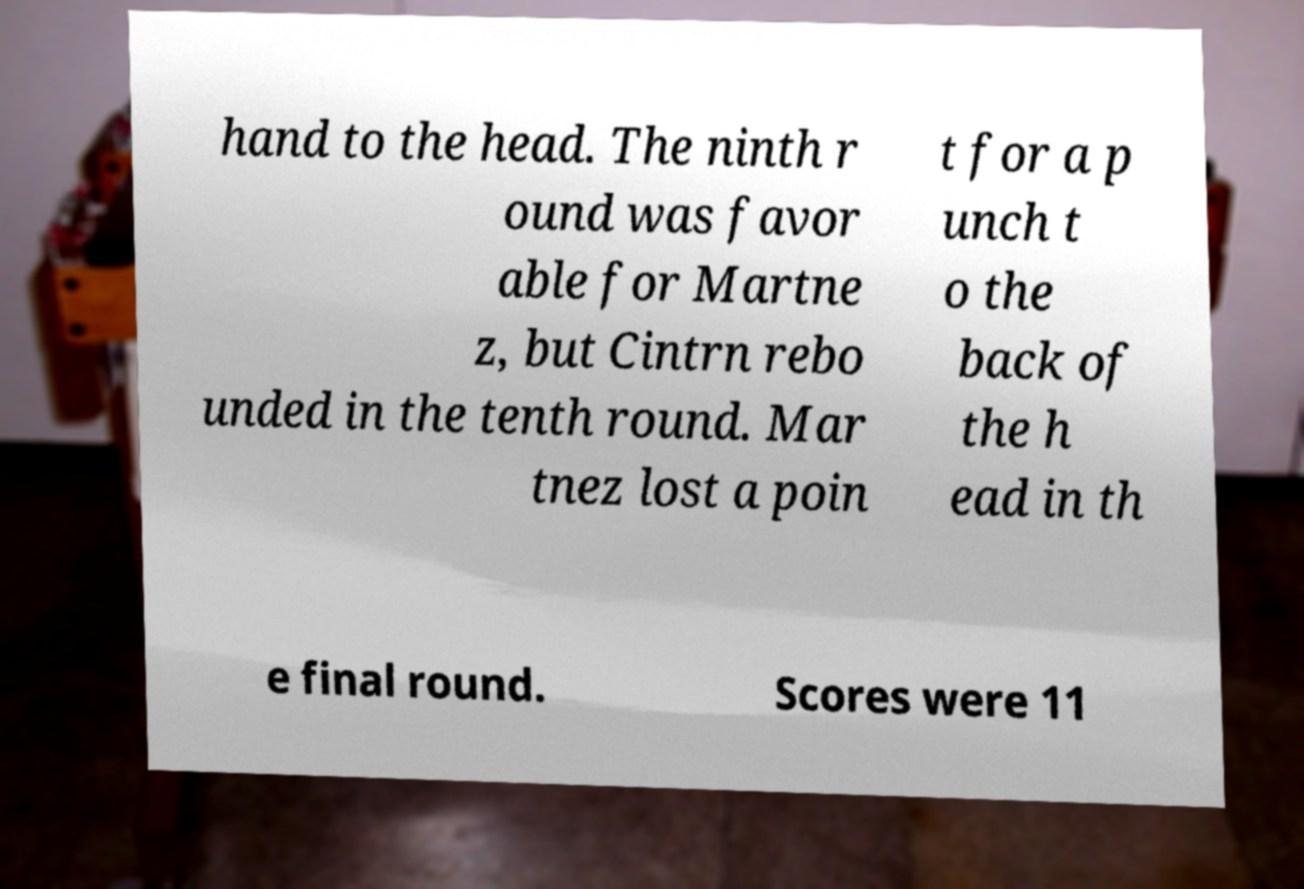There's text embedded in this image that I need extracted. Can you transcribe it verbatim? hand to the head. The ninth r ound was favor able for Martne z, but Cintrn rebo unded in the tenth round. Mar tnez lost a poin t for a p unch t o the back of the h ead in th e final round. Scores were 11 